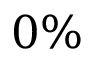Convert formula to latex. <formula><loc_0><loc_0><loc_500><loc_500>0 \%</formula> 